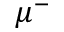Convert formula to latex. <formula><loc_0><loc_0><loc_500><loc_500>\mu ^ { - }</formula> 